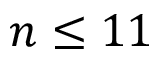<formula> <loc_0><loc_0><loc_500><loc_500>n \leq 1 1</formula> 